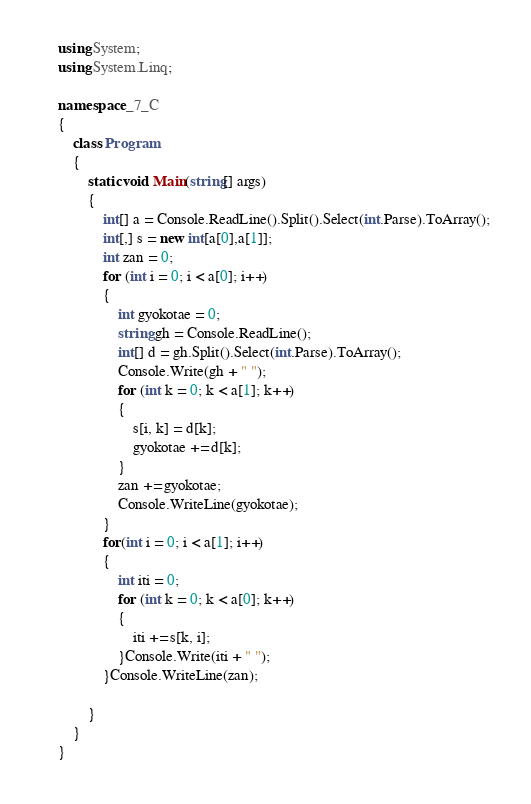Convert code to text. <code><loc_0><loc_0><loc_500><loc_500><_C#_>using System;
using System.Linq;

namespace _7_C
{
    class Program
    {
        static void Main(string[] args)
        {
            int[] a = Console.ReadLine().Split().Select(int.Parse).ToArray();
            int[,] s = new int[a[0],a[1]];
            int zan = 0;
            for (int i = 0; i < a[0]; i++)
            {
                int gyokotae = 0;
                string gh = Console.ReadLine();
                int[] d = gh.Split().Select(int.Parse).ToArray();
                Console.Write(gh + " ");
                for (int k = 0; k < a[1]; k++)
                {
                    s[i, k] = d[k];
                    gyokotae += d[k];
                }
                zan += gyokotae;
                Console.WriteLine(gyokotae);
            }
            for(int i = 0; i < a[1]; i++)
            {
                int iti = 0;
                for (int k = 0; k < a[0]; k++)
                {
                    iti += s[k, i];
                }Console.Write(iti + " ");
            }Console.WriteLine(zan);

        }
    }
}</code> 